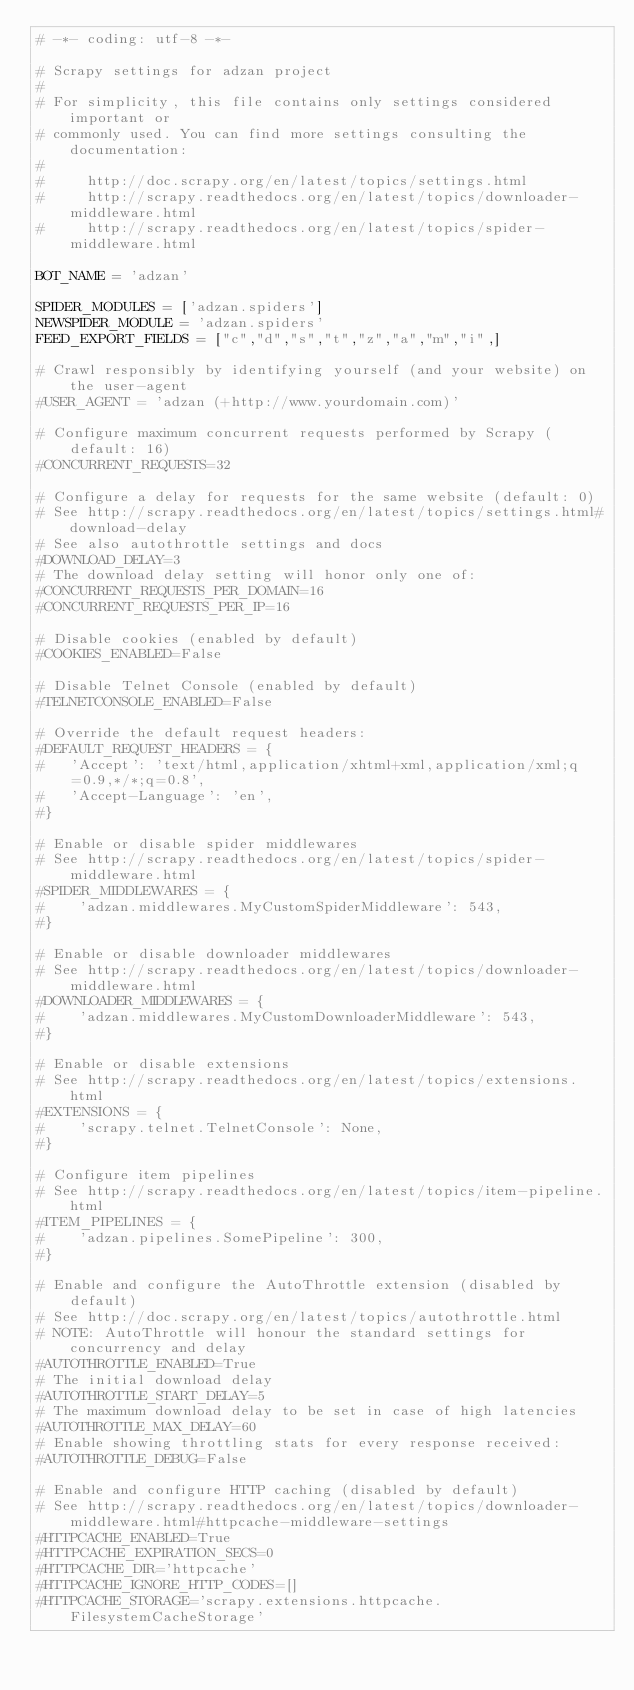Convert code to text. <code><loc_0><loc_0><loc_500><loc_500><_Python_># -*- coding: utf-8 -*-

# Scrapy settings for adzan project
#
# For simplicity, this file contains only settings considered important or
# commonly used. You can find more settings consulting the documentation:
#
#     http://doc.scrapy.org/en/latest/topics/settings.html
#     http://scrapy.readthedocs.org/en/latest/topics/downloader-middleware.html
#     http://scrapy.readthedocs.org/en/latest/topics/spider-middleware.html

BOT_NAME = 'adzan'

SPIDER_MODULES = ['adzan.spiders']
NEWSPIDER_MODULE = 'adzan.spiders'
FEED_EXPORT_FIELDS = ["c","d","s","t","z","a","m","i",]

# Crawl responsibly by identifying yourself (and your website) on the user-agent
#USER_AGENT = 'adzan (+http://www.yourdomain.com)'

# Configure maximum concurrent requests performed by Scrapy (default: 16)
#CONCURRENT_REQUESTS=32

# Configure a delay for requests for the same website (default: 0)
# See http://scrapy.readthedocs.org/en/latest/topics/settings.html#download-delay
# See also autothrottle settings and docs
#DOWNLOAD_DELAY=3
# The download delay setting will honor only one of:
#CONCURRENT_REQUESTS_PER_DOMAIN=16
#CONCURRENT_REQUESTS_PER_IP=16

# Disable cookies (enabled by default)
#COOKIES_ENABLED=False

# Disable Telnet Console (enabled by default)
#TELNETCONSOLE_ENABLED=False

# Override the default request headers:
#DEFAULT_REQUEST_HEADERS = {
#   'Accept': 'text/html,application/xhtml+xml,application/xml;q=0.9,*/*;q=0.8',
#   'Accept-Language': 'en',
#}

# Enable or disable spider middlewares
# See http://scrapy.readthedocs.org/en/latest/topics/spider-middleware.html
#SPIDER_MIDDLEWARES = {
#    'adzan.middlewares.MyCustomSpiderMiddleware': 543,
#}

# Enable or disable downloader middlewares
# See http://scrapy.readthedocs.org/en/latest/topics/downloader-middleware.html
#DOWNLOADER_MIDDLEWARES = {
#    'adzan.middlewares.MyCustomDownloaderMiddleware': 543,
#}

# Enable or disable extensions
# See http://scrapy.readthedocs.org/en/latest/topics/extensions.html
#EXTENSIONS = {
#    'scrapy.telnet.TelnetConsole': None,
#}

# Configure item pipelines
# See http://scrapy.readthedocs.org/en/latest/topics/item-pipeline.html
#ITEM_PIPELINES = {
#    'adzan.pipelines.SomePipeline': 300,
#}

# Enable and configure the AutoThrottle extension (disabled by default)
# See http://doc.scrapy.org/en/latest/topics/autothrottle.html
# NOTE: AutoThrottle will honour the standard settings for concurrency and delay
#AUTOTHROTTLE_ENABLED=True
# The initial download delay
#AUTOTHROTTLE_START_DELAY=5
# The maximum download delay to be set in case of high latencies
#AUTOTHROTTLE_MAX_DELAY=60
# Enable showing throttling stats for every response received:
#AUTOTHROTTLE_DEBUG=False

# Enable and configure HTTP caching (disabled by default)
# See http://scrapy.readthedocs.org/en/latest/topics/downloader-middleware.html#httpcache-middleware-settings
#HTTPCACHE_ENABLED=True
#HTTPCACHE_EXPIRATION_SECS=0
#HTTPCACHE_DIR='httpcache'
#HTTPCACHE_IGNORE_HTTP_CODES=[]
#HTTPCACHE_STORAGE='scrapy.extensions.httpcache.FilesystemCacheStorage'
</code> 